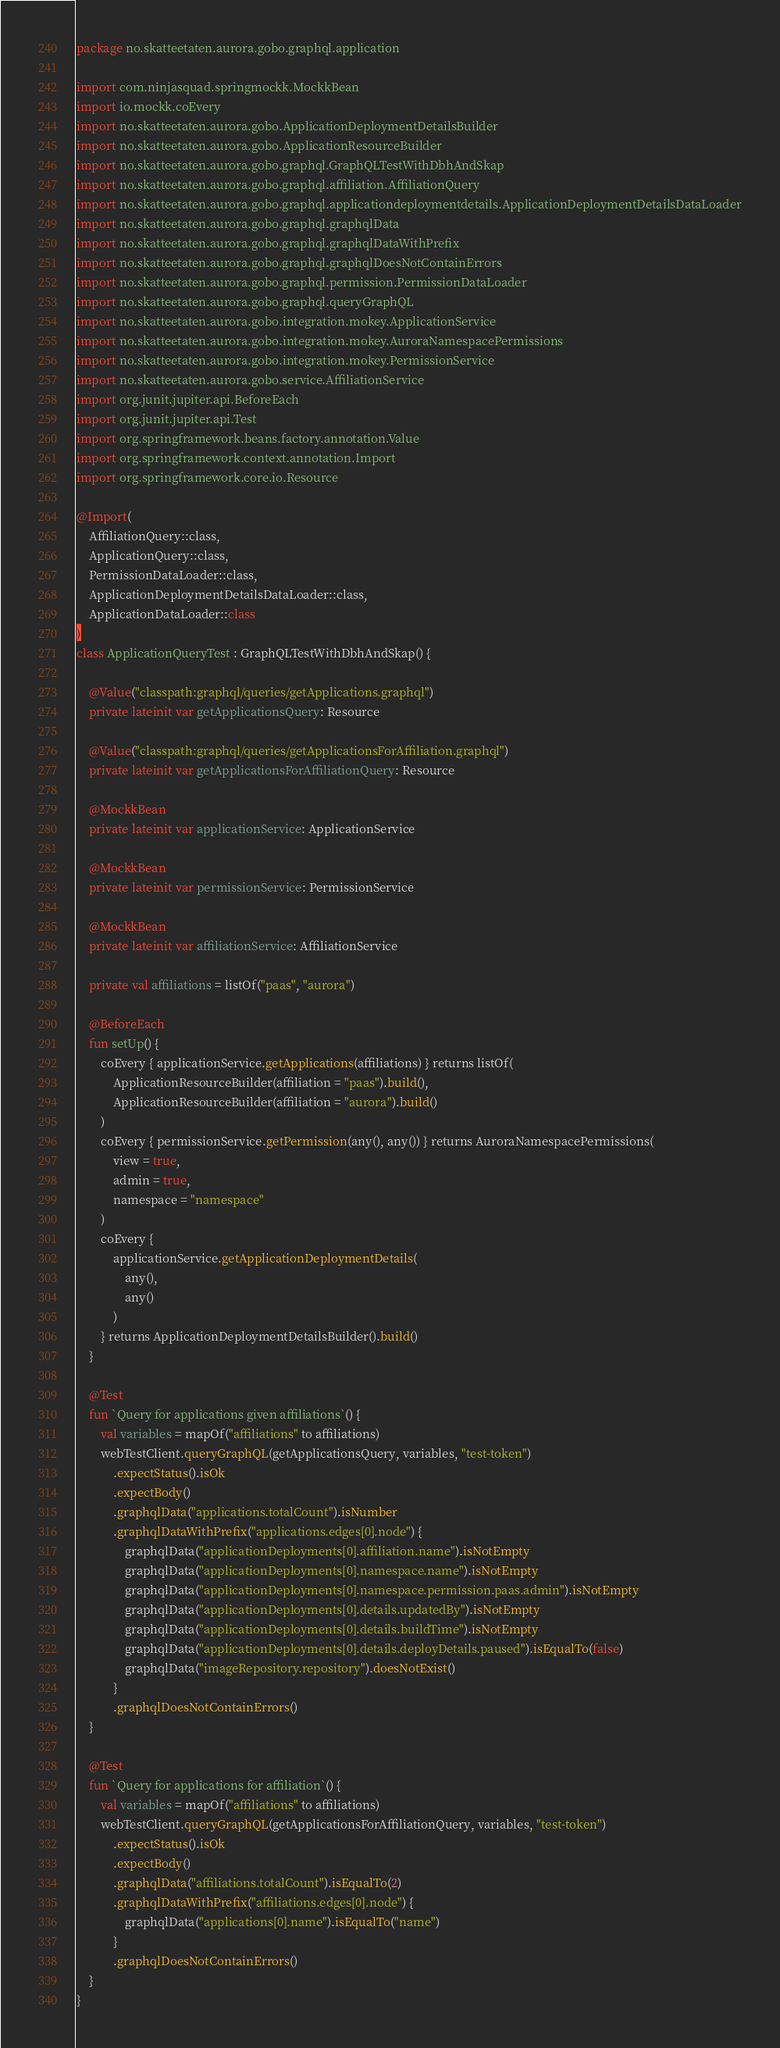Convert code to text. <code><loc_0><loc_0><loc_500><loc_500><_Kotlin_>package no.skatteetaten.aurora.gobo.graphql.application

import com.ninjasquad.springmockk.MockkBean
import io.mockk.coEvery
import no.skatteetaten.aurora.gobo.ApplicationDeploymentDetailsBuilder
import no.skatteetaten.aurora.gobo.ApplicationResourceBuilder
import no.skatteetaten.aurora.gobo.graphql.GraphQLTestWithDbhAndSkap
import no.skatteetaten.aurora.gobo.graphql.affiliation.AffiliationQuery
import no.skatteetaten.aurora.gobo.graphql.applicationdeploymentdetails.ApplicationDeploymentDetailsDataLoader
import no.skatteetaten.aurora.gobo.graphql.graphqlData
import no.skatteetaten.aurora.gobo.graphql.graphqlDataWithPrefix
import no.skatteetaten.aurora.gobo.graphql.graphqlDoesNotContainErrors
import no.skatteetaten.aurora.gobo.graphql.permission.PermissionDataLoader
import no.skatteetaten.aurora.gobo.graphql.queryGraphQL
import no.skatteetaten.aurora.gobo.integration.mokey.ApplicationService
import no.skatteetaten.aurora.gobo.integration.mokey.AuroraNamespacePermissions
import no.skatteetaten.aurora.gobo.integration.mokey.PermissionService
import no.skatteetaten.aurora.gobo.service.AffiliationService
import org.junit.jupiter.api.BeforeEach
import org.junit.jupiter.api.Test
import org.springframework.beans.factory.annotation.Value
import org.springframework.context.annotation.Import
import org.springframework.core.io.Resource

@Import(
    AffiliationQuery::class,
    ApplicationQuery::class,
    PermissionDataLoader::class,
    ApplicationDeploymentDetailsDataLoader::class,
    ApplicationDataLoader::class
)
class ApplicationQueryTest : GraphQLTestWithDbhAndSkap() {

    @Value("classpath:graphql/queries/getApplications.graphql")
    private lateinit var getApplicationsQuery: Resource

    @Value("classpath:graphql/queries/getApplicationsForAffiliation.graphql")
    private lateinit var getApplicationsForAffiliationQuery: Resource

    @MockkBean
    private lateinit var applicationService: ApplicationService

    @MockkBean
    private lateinit var permissionService: PermissionService

    @MockkBean
    private lateinit var affiliationService: AffiliationService

    private val affiliations = listOf("paas", "aurora")

    @BeforeEach
    fun setUp() {
        coEvery { applicationService.getApplications(affiliations) } returns listOf(
            ApplicationResourceBuilder(affiliation = "paas").build(),
            ApplicationResourceBuilder(affiliation = "aurora").build()
        )
        coEvery { permissionService.getPermission(any(), any()) } returns AuroraNamespacePermissions(
            view = true,
            admin = true,
            namespace = "namespace"
        )
        coEvery {
            applicationService.getApplicationDeploymentDetails(
                any(),
                any()
            )
        } returns ApplicationDeploymentDetailsBuilder().build()
    }

    @Test
    fun `Query for applications given affiliations`() {
        val variables = mapOf("affiliations" to affiliations)
        webTestClient.queryGraphQL(getApplicationsQuery, variables, "test-token")
            .expectStatus().isOk
            .expectBody()
            .graphqlData("applications.totalCount").isNumber
            .graphqlDataWithPrefix("applications.edges[0].node") {
                graphqlData("applicationDeployments[0].affiliation.name").isNotEmpty
                graphqlData("applicationDeployments[0].namespace.name").isNotEmpty
                graphqlData("applicationDeployments[0].namespace.permission.paas.admin").isNotEmpty
                graphqlData("applicationDeployments[0].details.updatedBy").isNotEmpty
                graphqlData("applicationDeployments[0].details.buildTime").isNotEmpty
                graphqlData("applicationDeployments[0].details.deployDetails.paused").isEqualTo(false)
                graphqlData("imageRepository.repository").doesNotExist()
            }
            .graphqlDoesNotContainErrors()
    }

    @Test
    fun `Query for applications for affiliation`() {
        val variables = mapOf("affiliations" to affiliations)
        webTestClient.queryGraphQL(getApplicationsForAffiliationQuery, variables, "test-token")
            .expectStatus().isOk
            .expectBody()
            .graphqlData("affiliations.totalCount").isEqualTo(2)
            .graphqlDataWithPrefix("affiliations.edges[0].node") {
                graphqlData("applications[0].name").isEqualTo("name")
            }
            .graphqlDoesNotContainErrors()
    }
}
</code> 